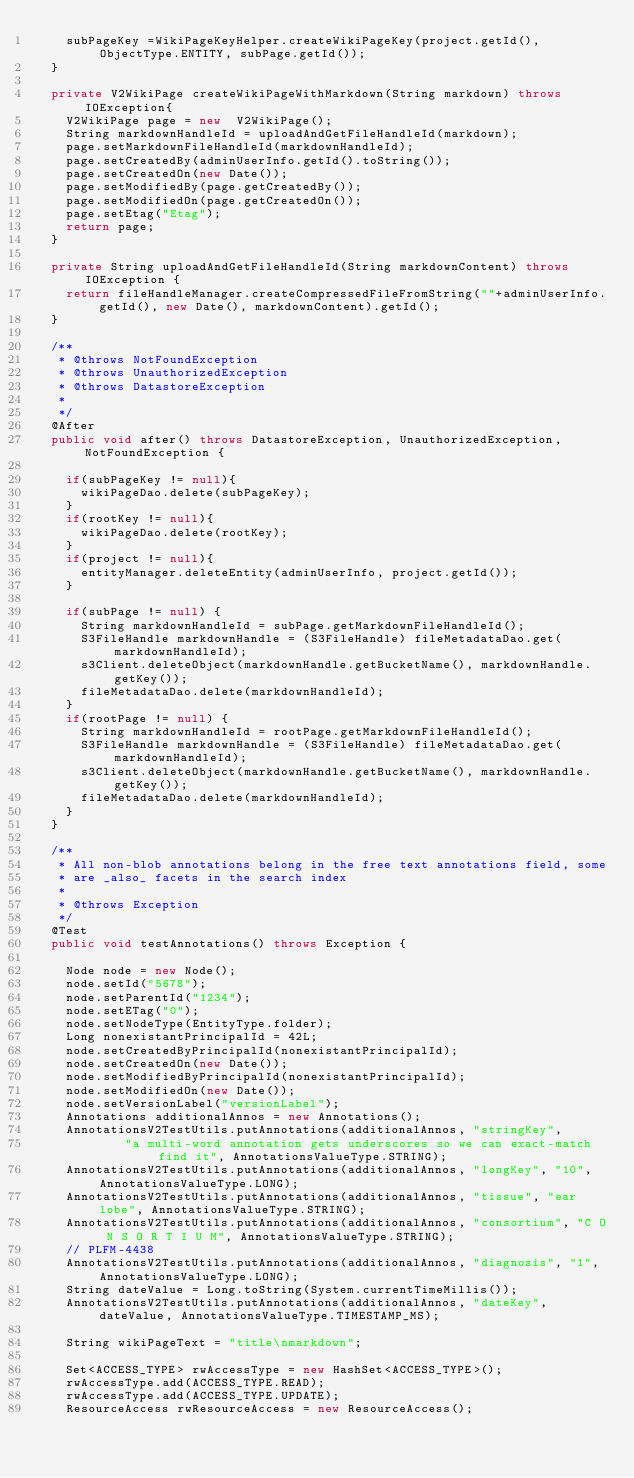Convert code to text. <code><loc_0><loc_0><loc_500><loc_500><_Java_>		subPageKey =WikiPageKeyHelper.createWikiPageKey(project.getId(), ObjectType.ENTITY, subPage.getId());
	}
	
	private V2WikiPage createWikiPageWithMarkdown(String markdown) throws IOException{
		V2WikiPage page = new  V2WikiPage();
		String markdownHandleId = uploadAndGetFileHandleId(markdown);
		page.setMarkdownFileHandleId(markdownHandleId);
		page.setCreatedBy(adminUserInfo.getId().toString());
		page.setCreatedOn(new Date());
		page.setModifiedBy(page.getCreatedBy());
		page.setModifiedOn(page.getCreatedOn());
		page.setEtag("Etag");
		return page;
	}
	
	private String uploadAndGetFileHandleId(String markdownContent) throws IOException {	
		return fileHandleManager.createCompressedFileFromString(""+adminUserInfo.getId(), new Date(), markdownContent).getId();
	}
	
	/**
	 * @throws NotFoundException 
	 * @throws UnauthorizedException 
	 * @throws DatastoreException 
	 * 
	 */
	@After
	public void after() throws DatastoreException, UnauthorizedException, NotFoundException {
		
		if(subPageKey != null){
			wikiPageDao.delete(subPageKey);
		}
		if(rootKey != null){
			wikiPageDao.delete(rootKey);
		}
		if(project != null){
			entityManager.deleteEntity(adminUserInfo, project.getId());
		}
		
		if(subPage != null) {
			String markdownHandleId = subPage.getMarkdownFileHandleId();
			S3FileHandle markdownHandle = (S3FileHandle) fileMetadataDao.get(markdownHandleId);
			s3Client.deleteObject(markdownHandle.getBucketName(), markdownHandle.getKey());
			fileMetadataDao.delete(markdownHandleId);
		}
		if(rootPage != null) {
			String markdownHandleId = rootPage.getMarkdownFileHandleId();
			S3FileHandle markdownHandle = (S3FileHandle) fileMetadataDao.get(markdownHandleId);
			s3Client.deleteObject(markdownHandle.getBucketName(), markdownHandle.getKey());
			fileMetadataDao.delete(markdownHandleId);
		}
	}

	/**
	 * All non-blob annotations belong in the free text annotations field, some
	 * are _also_ facets in the search index
	 * 
	 * @throws Exception
	 */
	@Test
	public void testAnnotations() throws Exception {

		Node node = new Node();
		node.setId("5678");
		node.setParentId("1234");
		node.setETag("0");
		node.setNodeType(EntityType.folder);
		Long nonexistantPrincipalId = 42L;
		node.setCreatedByPrincipalId(nonexistantPrincipalId);
		node.setCreatedOn(new Date());
		node.setModifiedByPrincipalId(nonexistantPrincipalId);
		node.setModifiedOn(new Date());
		node.setVersionLabel("versionLabel");
		Annotations additionalAnnos = new Annotations();
		AnnotationsV2TestUtils.putAnnotations(additionalAnnos, "stringKey",
						"a multi-word annotation gets underscores so we can exact-match find it", AnnotationsValueType.STRING);
		AnnotationsV2TestUtils.putAnnotations(additionalAnnos, "longKey", "10", AnnotationsValueType.LONG);
		AnnotationsV2TestUtils.putAnnotations(additionalAnnos, "tissue", "ear lobe", AnnotationsValueType.STRING);
		AnnotationsV2TestUtils.putAnnotations(additionalAnnos, "consortium", "C O N S O R T I U M", AnnotationsValueType.STRING);
		// PLFM-4438
		AnnotationsV2TestUtils.putAnnotations(additionalAnnos, "diagnosis", "1", AnnotationsValueType.LONG);
		String dateValue = Long.toString(System.currentTimeMillis());
		AnnotationsV2TestUtils.putAnnotations(additionalAnnos, "dateKey", dateValue, AnnotationsValueType.TIMESTAMP_MS);
		
		String wikiPageText = "title\nmarkdown";

		Set<ACCESS_TYPE> rwAccessType = new HashSet<ACCESS_TYPE>();
		rwAccessType.add(ACCESS_TYPE.READ);
		rwAccessType.add(ACCESS_TYPE.UPDATE);
		ResourceAccess rwResourceAccess = new ResourceAccess();</code> 